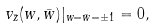Convert formula to latex. <formula><loc_0><loc_0><loc_500><loc_500>v _ { \bar { z } } ( w , \bar { w } ) | _ { w = \bar { w } = \pm 1 } = 0 ,</formula> 